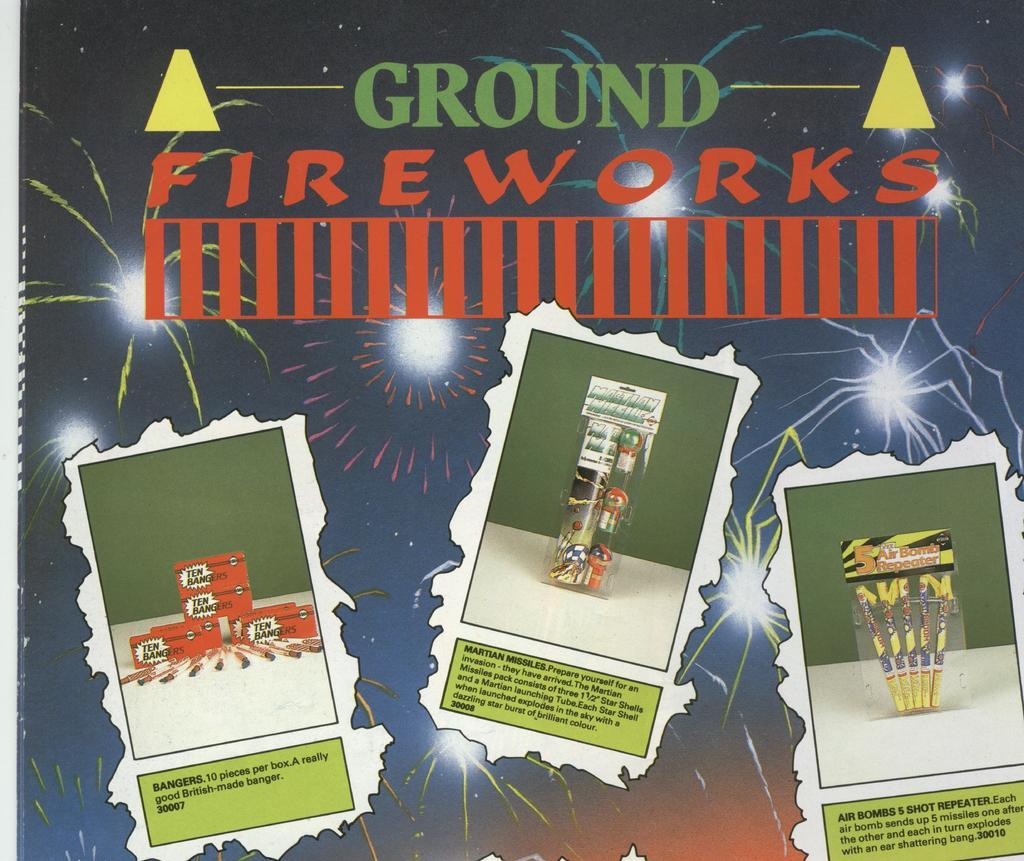What type of visual is the image? The image is a poster. What can be found on the poster besides images? There is text on the poster. What type of food is depicted on the poster? There are images of crackers on the poster. What other type of object is shown on the poster besides food? There are images of boxes on the poster. Where is the parcel located in the image? There is no parcel present in the image. What type of bird can be seen in the image? There is no bird, including a turkey, present in the image. 